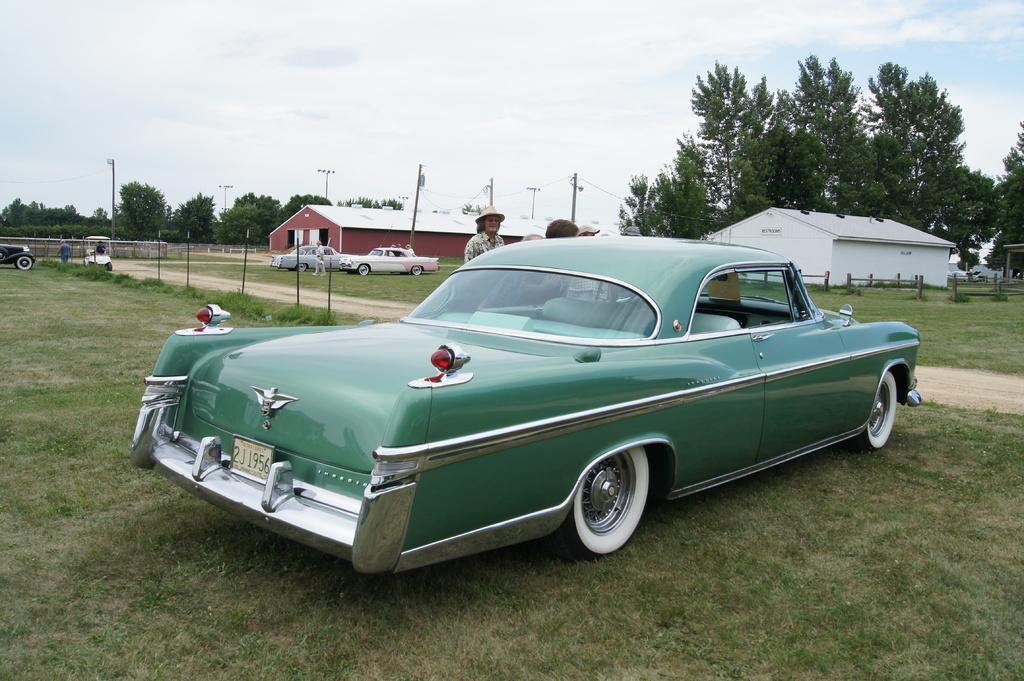Could you give a brief overview of what you see in this image? In this image there are cars and we can see people. At the bottom there is grass. In the background there are sheds, trees, poles and sky. 